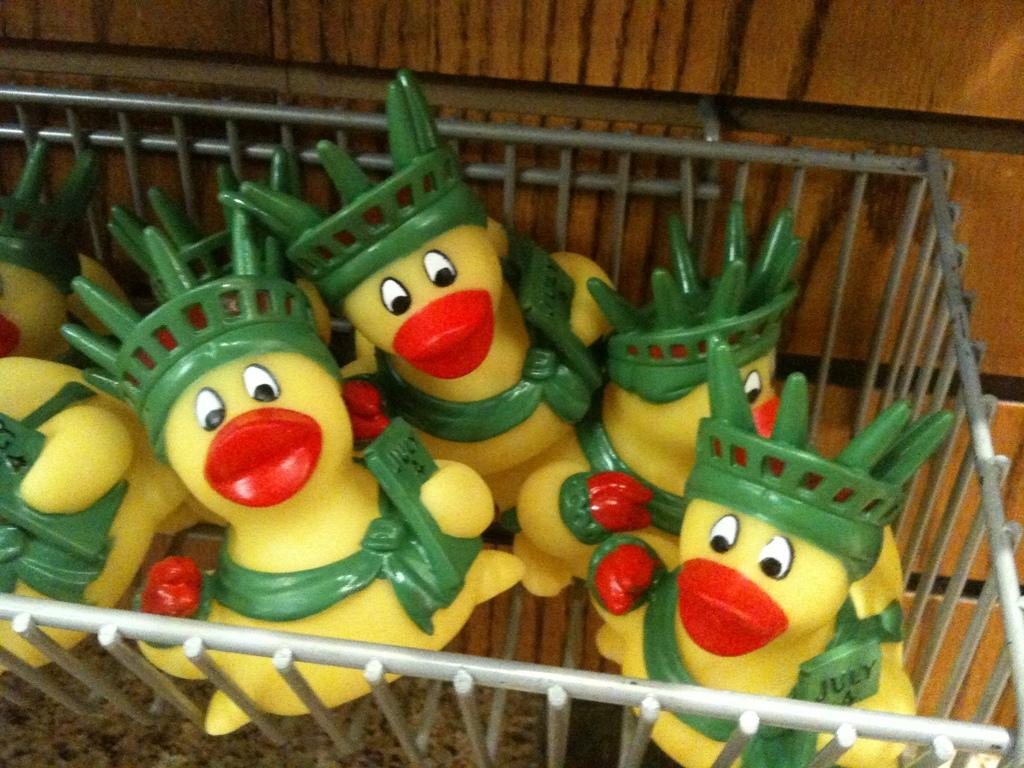What object is present in the image that can hold items? There is a metal basket in the image. What is inside the metal basket? The metal basket contains toy ducks. What can be seen in the background of the image? There is a wall in the background of the image. What type of feather can be seen on the toy ducks in the image? There are no feathers present on the toy ducks in the image, as they are likely made of plastic or another material. 